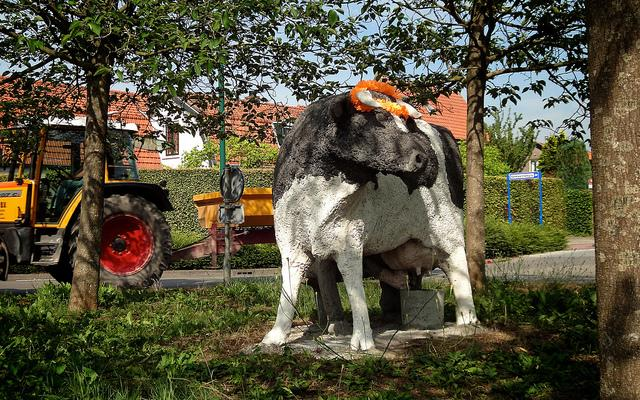What feature of the animal is visible?

Choices:
A) wing
B) gill
C) udder
D) stinger udder 